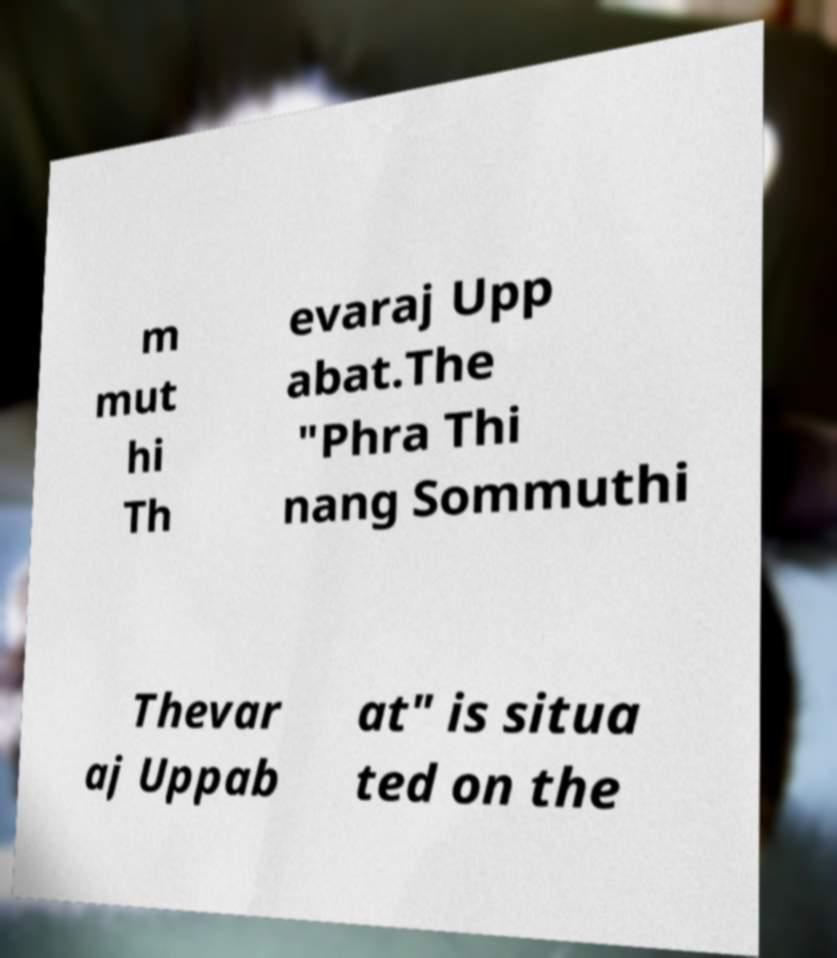For documentation purposes, I need the text within this image transcribed. Could you provide that? m mut hi Th evaraj Upp abat.The "Phra Thi nang Sommuthi Thevar aj Uppab at" is situa ted on the 